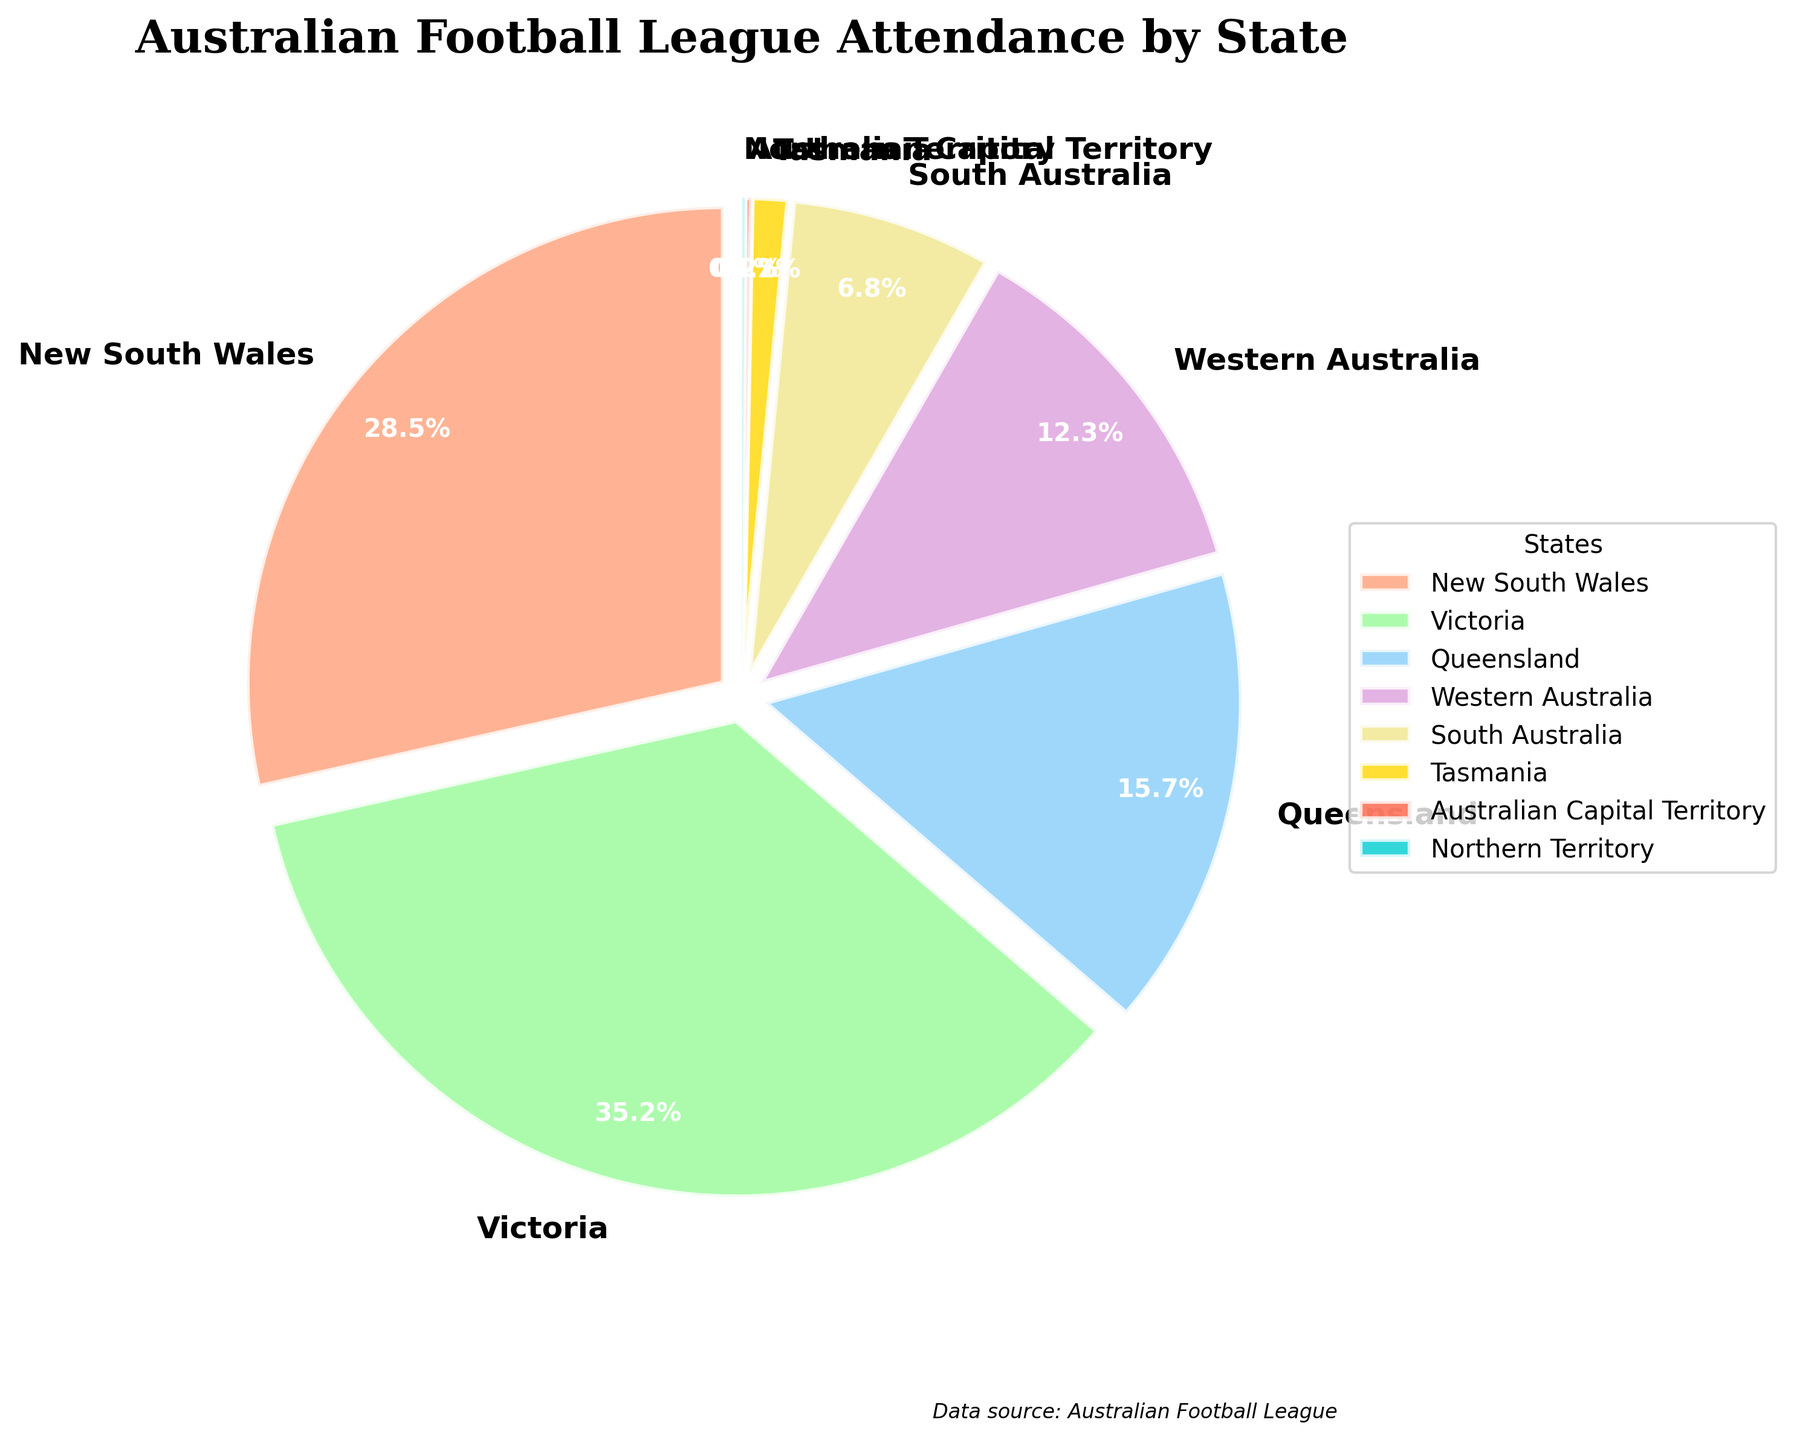What is the percentage of total attendance from New South Wales and Victoria combined? To find the combined percentage, add the individual percentages of New South Wales (28.5%) and Victoria (35.2%): 28.5 + 35.2 = 63.7%.
Answer: 63.7% Which state has the highest attendance percentage? The highest attendance percentage is identified as the largest segment in the pie chart. Victoria has the highest percentage at 35.2%.
Answer: Victoria How much more is Victoria's attendance percentage compared to Queensland's? To find the difference, subtract Queensland's percentage (15.7%) from Victoria's (35.2%): 35.2 - 15.7 = 19.5%.
Answer: 19.5% By how many percentage points does New South Wales exceed Western Australia's attendance percentage? Subtract Western Australia's percentage (12.3%) from New South Wales's (28.5%): 28.5 - 12.3 = 16.2%.
Answer: 16.2% What is the combined attendance percentage of the states with the three lowest percentages of attendance? Identify the three states with the lowest percentages: Northern Territory (0.1%), Australian Capital Territory (0.2%), and Tasmania (1.2%). Add them together: 0.1 + 0.2 + 1.2 = 1.5%.
Answer: 1.5% Which state is represented by the green segment in the pie chart? The green color in the pie chart represents Victoria, as indicated by the legend.
Answer: Victoria What is the total attendance percentage for Queensland and South Australia combined? Add Queensland's percentage (15.7%) with South Australia's (6.8%): 15.7 + 6.8 = 22.5%.
Answer: 22.5% Find the average attendance percentage of the states shown on the pie chart. Average percentage is found by summing all percentages and dividing by the number of states: (28.5 + 35.2 + 15.7 + 12.3 + 6.8 + 1.2 + 0.2 + 0.1) / 8 = 100 / 8 = 12.5%.
Answer: 12.5% Which state has an attendance percentage closest to 10%? The state with the attendance percentage closest to 10% is Western Australia at 12.3%.
Answer: Western Australia 